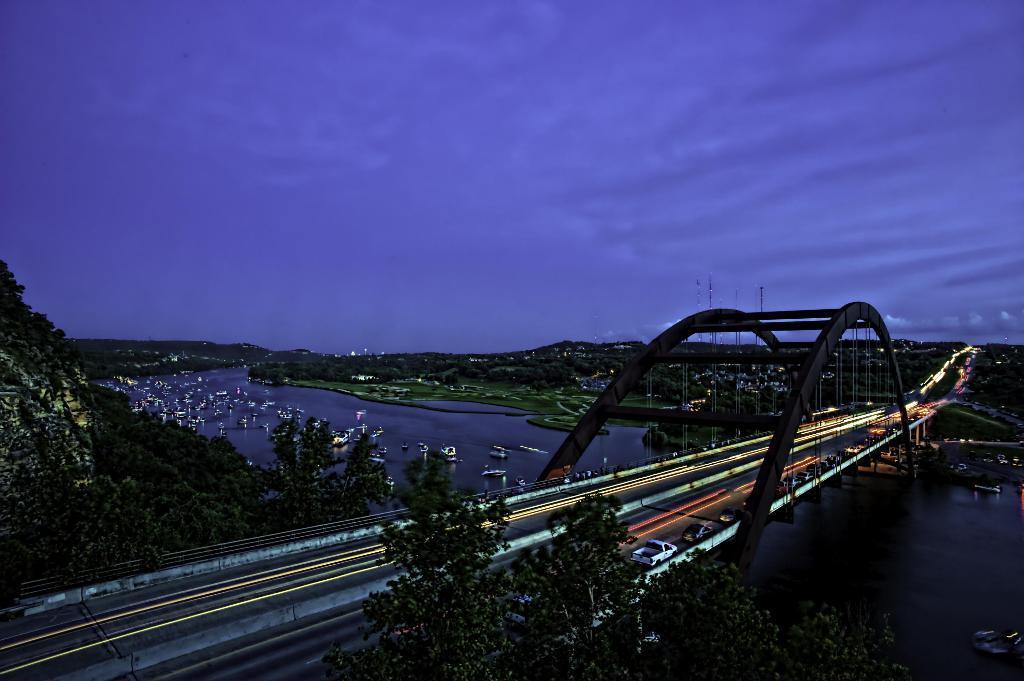Please provide a concise description of this image. In this image we can see a bridge with lights and vehicles on it. We can see the boats on the water. And there are trees, poles, mountains and sky in the background. 